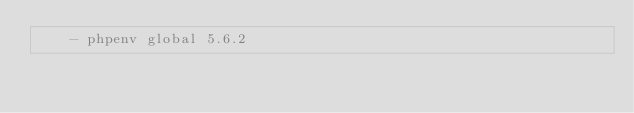<code> <loc_0><loc_0><loc_500><loc_500><_YAML_>    - phpenv global 5.6.2
</code> 